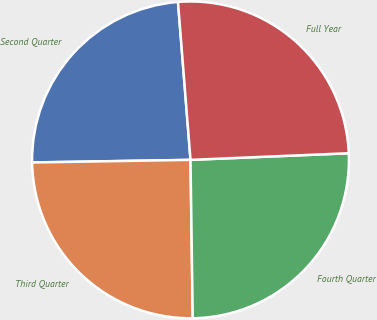Convert chart. <chart><loc_0><loc_0><loc_500><loc_500><pie_chart><fcel>Second Quarter<fcel>Third Quarter<fcel>Fourth Quarter<fcel>Full Year<nl><fcel>24.0%<fcel>24.96%<fcel>25.44%<fcel>25.59%<nl></chart> 